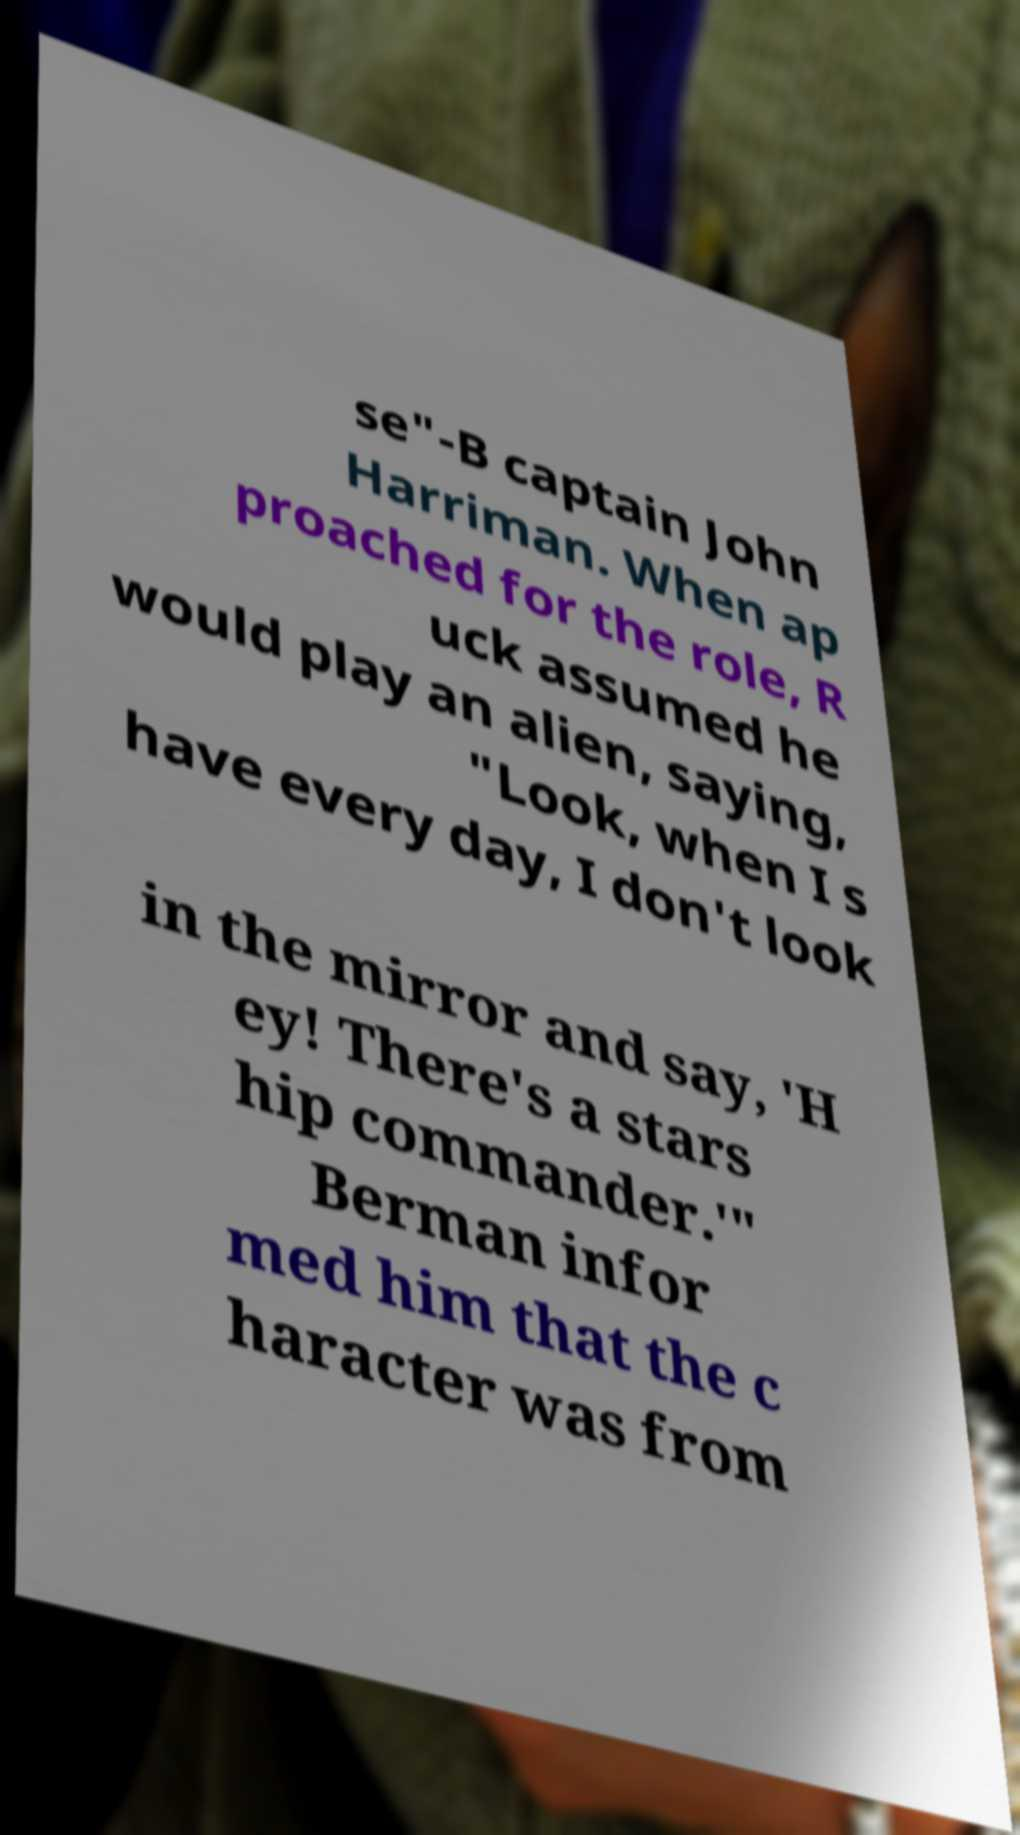Please identify and transcribe the text found in this image. se"-B captain John Harriman. When ap proached for the role, R uck assumed he would play an alien, saying, "Look, when I s have every day, I don't look in the mirror and say, 'H ey! There's a stars hip commander.'" Berman infor med him that the c haracter was from 